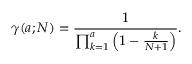Convert formula to latex. <formula><loc_0><loc_0><loc_500><loc_500>\gamma ( a ; N ) = { \frac { 1 } { \prod _ { k = 1 } ^ { a } \left ( 1 - { \frac { k } { N + 1 } } \right ) } } .</formula> 